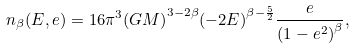<formula> <loc_0><loc_0><loc_500><loc_500>n _ { \beta } ( E , e ) = 1 6 \pi ^ { 3 } { ( G M ) } ^ { 3 - 2 \beta } { ( - 2 E ) } ^ { \beta - \frac { 5 } { 2 } } \frac { e } { { ( 1 - e ^ { 2 } ) } ^ { \beta } } ,</formula> 